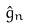Convert formula to latex. <formula><loc_0><loc_0><loc_500><loc_500>\hat { g } _ { n }</formula> 